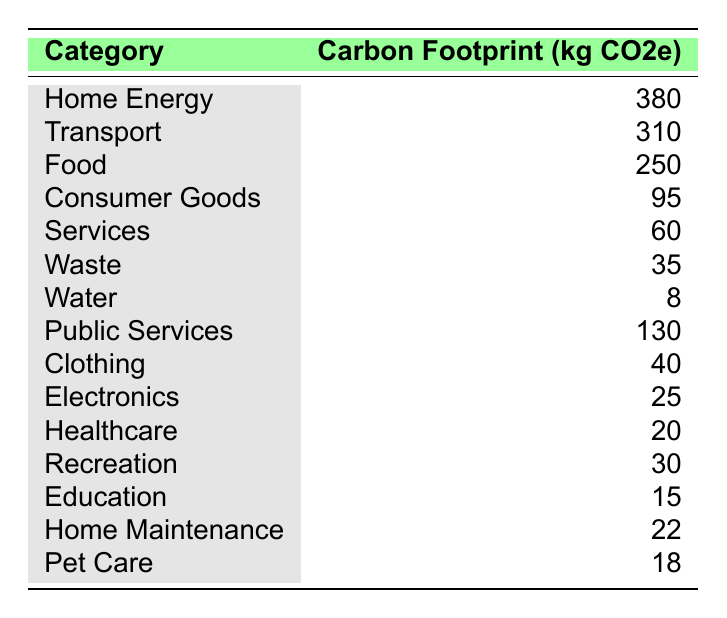What is the carbon footprint associated with Home Energy? The table shows that the carbon footprint for the Home Energy category is listed as 380 kg CO2e.
Answer: 380 Which category has the highest carbon footprint? By looking at the table, the highest carbon footprint is for Home Energy with 380 kg CO2e.
Answer: Home Energy What is the combined carbon footprint of Food and Transport? The carbon footprint for Food is 250 kg CO2e, and for Transport, it is 310 kg CO2e. Adding these together: 250 + 310 = 560 kg CO2e.
Answer: 560 What percentage of the total carbon footprint is attributed to Services? The total carbon footprint can be calculated by summing all categories: 380 + 310 + 250 + 95 + 60 + 35 + 8 + 130 + 40 + 25 + 20 + 30 + 15 + 22 + 18 =  1,618 kg CO2e. The Services category contributes 60 kg CO2e. The percentage is (60/1618) * 100 ≈ 3.70%.
Answer: 3.70% Is the carbon footprint of Waste greater than that of Water? The table lists Waste as 35 kg CO2e and Water as 8 kg CO2e. Since 35 is greater than 8, the answer is yes.
Answer: Yes What is the difference in carbon footprint between Transport and Consumer Goods? Transport has a carbon footprint of 310 kg CO2e and Consumer Goods has 95 kg CO2e. The difference is 310 - 95 = 215 kg CO2e.
Answer: 215 Which categories contribute a carbon footprint of less than 30 kg CO2e? The categories with less than 30 kg CO2e are Electronics (25 kg CO2e), Healthcare (20 kg CO2e), Education (15 kg CO2e), and Pet Care (18 kg CO2e).
Answer: Electronics, Healthcare, Education, Pet Care How much less is the carbon footprint of Clothing than that of Food? Clothing has a carbon footprint of 40 kg CO2e, while Food has 250 kg CO2e. The difference is calculated as 250 - 40 = 210 kg CO2e.
Answer: 210 What is the average carbon footprint across all categories? The total carbon footprint is 1,618 kg CO2e, and there are 14 categories. To find the average, divide 1,618 by 14, which gives approximately 115.57 kg CO2e.
Answer: 115.57 Does the carbon footprint from Consumer Goods exceed that from Pet Care? Consumer Goods has a carbon footprint of 95 kg CO2e, while Pet Care has 18 kg CO2e. Since 95 is greater than 18, the answer is yes.
Answer: Yes 